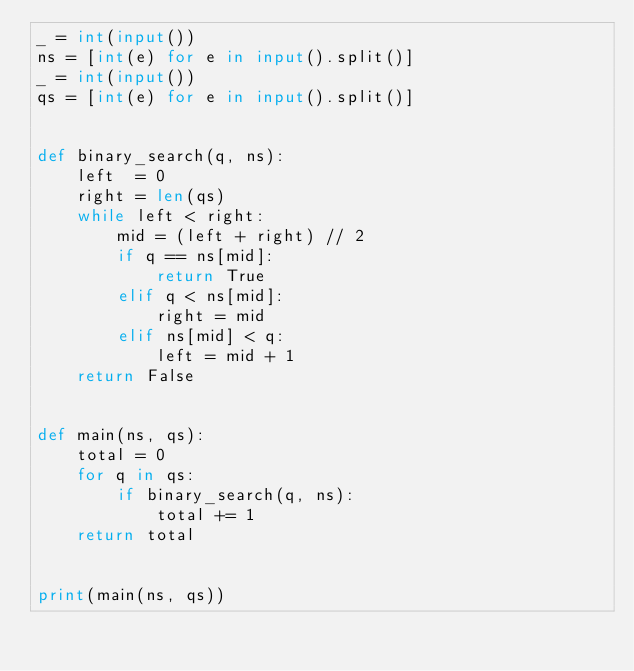Convert code to text. <code><loc_0><loc_0><loc_500><loc_500><_Python_>_ = int(input())
ns = [int(e) for e in input().split()]
_ = int(input())
qs = [int(e) for e in input().split()]


def binary_search(q, ns):
    left  = 0
    right = len(qs)
    while left < right:
        mid = (left + right) // 2
        if q == ns[mid]:
            return True
        elif q < ns[mid]:
            right = mid
        elif ns[mid] < q:
            left = mid + 1
    return False


def main(ns, qs):
    total = 0
    for q in qs:
        if binary_search(q, ns):
            total += 1
    return total


print(main(ns, qs))</code> 